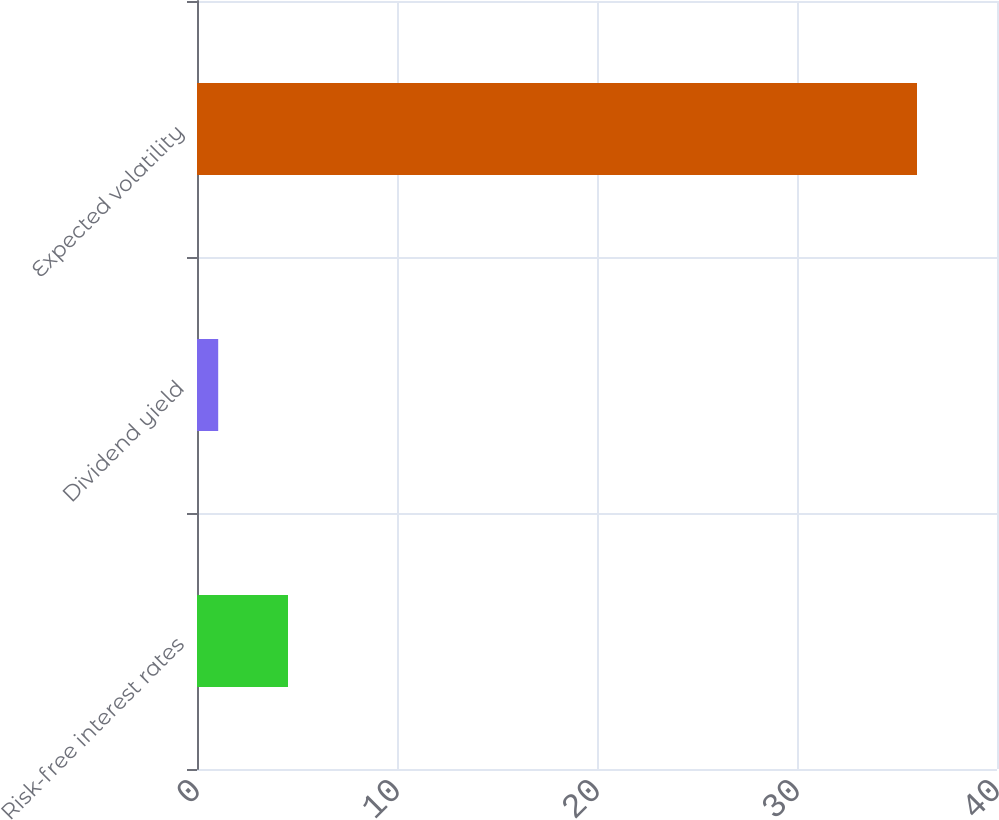Convert chart to OTSL. <chart><loc_0><loc_0><loc_500><loc_500><bar_chart><fcel>Risk-free interest rates<fcel>Dividend yield<fcel>Expected volatility<nl><fcel>4.55<fcel>1.06<fcel>36<nl></chart> 